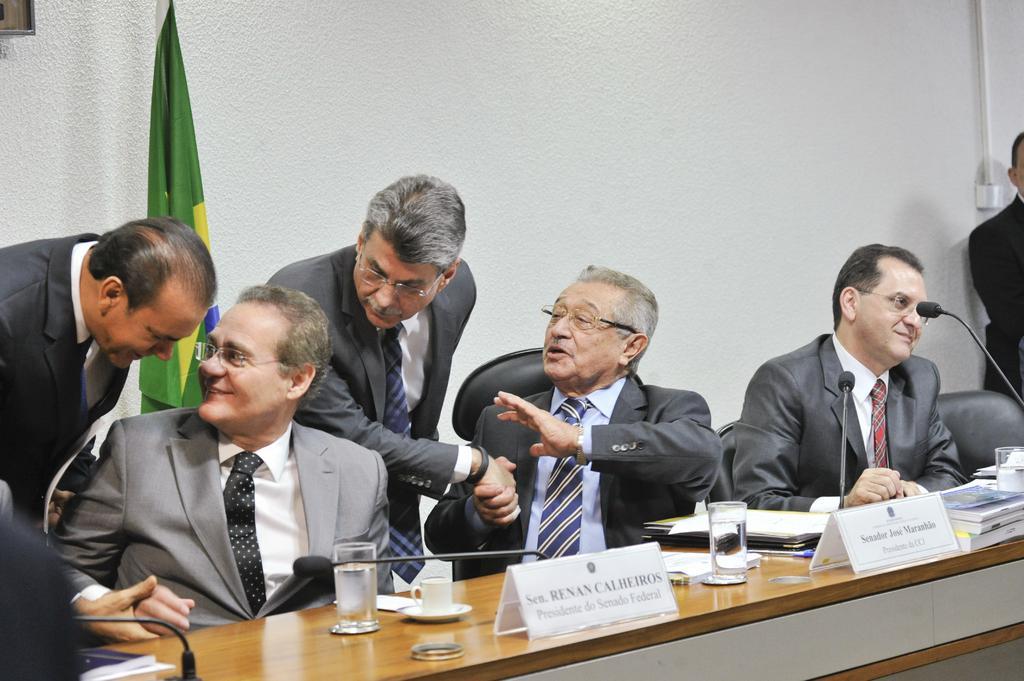Describe this image in one or two sentences. There are 3 people sitting on the chair and 3 men standing,behind them there is a flag and wall,in front of them there is a table on which microphone,glasses,cup and books are there. 